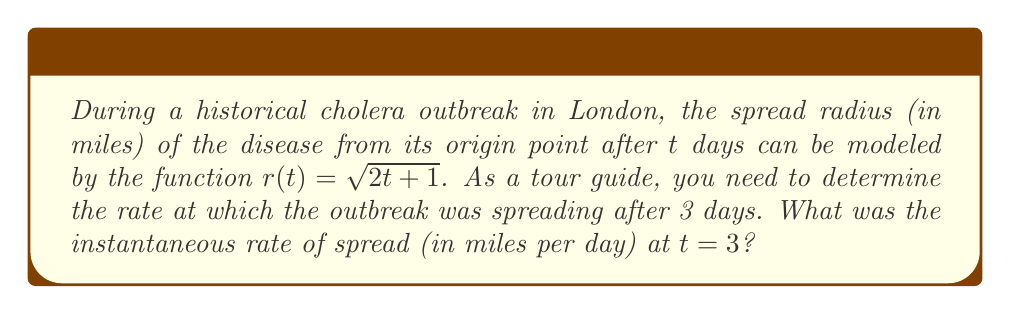What is the answer to this math problem? To find the instantaneous rate of spread at $t = 3$, we need to calculate the derivative of the function $r(t)$ and evaluate it at $t = 3$. Let's follow these steps:

1) The given function is $r(t) = \sqrt{2t + 1}$

2) To find the derivative, we use the chain rule:
   $$\frac{dr}{dt} = \frac{1}{2\sqrt{2t + 1}} \cdot \frac{d}{dt}(2t + 1)$$

3) Simplify:
   $$\frac{dr}{dt} = \frac{1}{2\sqrt{2t + 1}} \cdot 2 = \frac{1}{\sqrt{2t + 1}}$$

4) Now, we evaluate this derivative at $t = 3$:
   $$\left.\frac{dr}{dt}\right|_{t=3} = \frac{1}{\sqrt{2(3) + 1}} = \frac{1}{\sqrt{7}}$$

5) To simplify this fraction:
   $$\frac{1}{\sqrt{7}} = \frac{\sqrt{7}}{7}$$

This result represents the instantaneous rate of spread in miles per day at $t = 3$ days.
Answer: $\frac{\sqrt{7}}{7}$ miles per day 